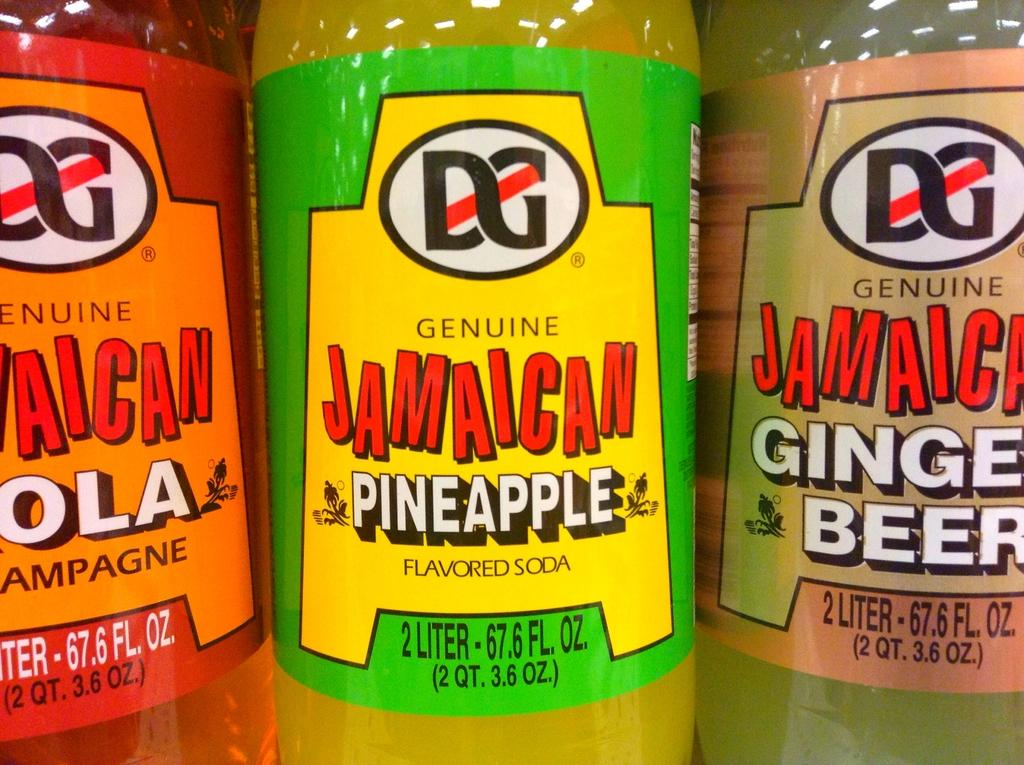<image>
Describe the image concisely. Three different flavors of Jamaican brand soda are next to each other. 